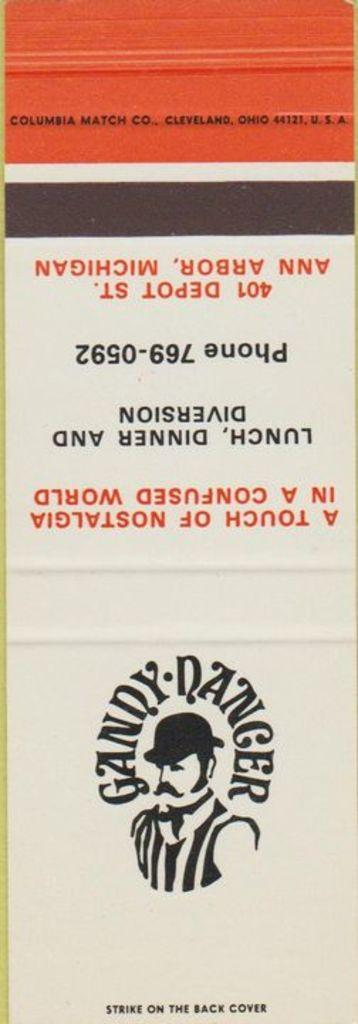What is present in the image that has an image and text? There is a poster in the image that has an image and text. Can you describe the image on the poster? The provided facts do not give information about the image on the poster, so we cannot describe it. What type of text is written on the poster? The provided facts do not give information about the type of text on the poster, so we cannot describe it. Is there a veil covering the poster in the image? There is no mention of a veil in the provided facts, so we cannot determine if there is one covering the poster in the image. How many quilts are visible on the poster in the image? There is no mention of quilts in the provided facts, so we cannot determine if there are any on the poster in the image. 